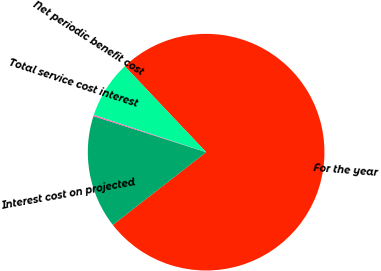Convert chart to OTSL. <chart><loc_0><loc_0><loc_500><loc_500><pie_chart><fcel>For the year<fcel>Interest cost on projected<fcel>Total service cost interest<fcel>Net periodic benefit cost<nl><fcel>76.53%<fcel>15.46%<fcel>0.19%<fcel>7.82%<nl></chart> 